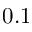Convert formula to latex. <formula><loc_0><loc_0><loc_500><loc_500>0 . 1</formula> 